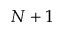Convert formula to latex. <formula><loc_0><loc_0><loc_500><loc_500>N + 1</formula> 